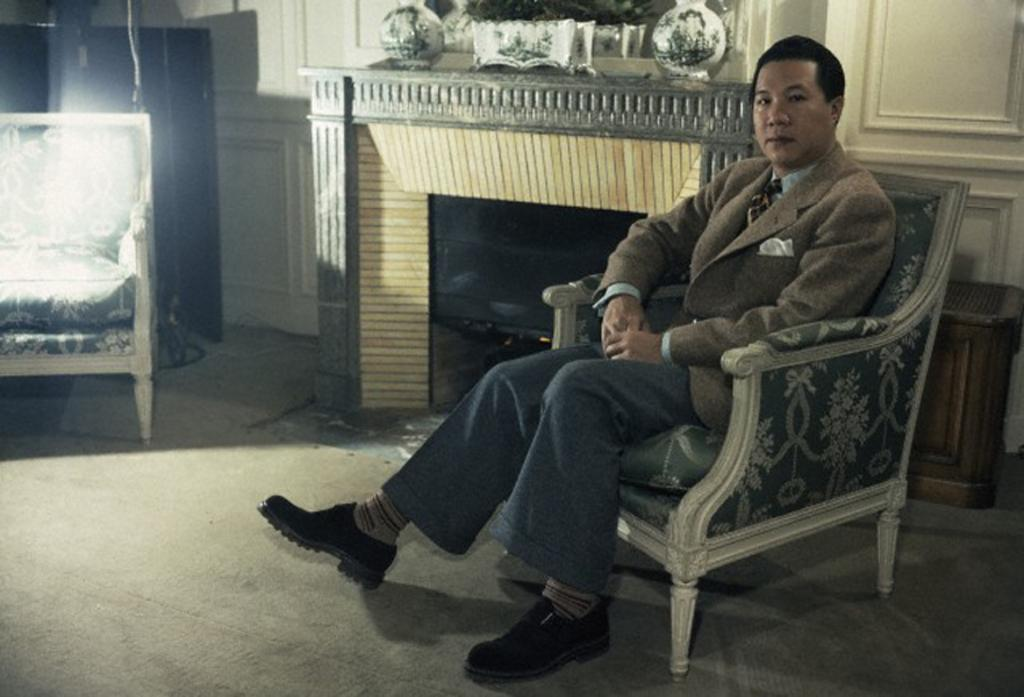Who is present in the image? There is a man in the image. What is the man doing in the image? The man is sitting on a chair. What can be seen in the background of the image? There is a building visible in the background of the image. How many feet are in the image? There is no reference to feet or any measurement in the image, so it's not possible to answer that question. 